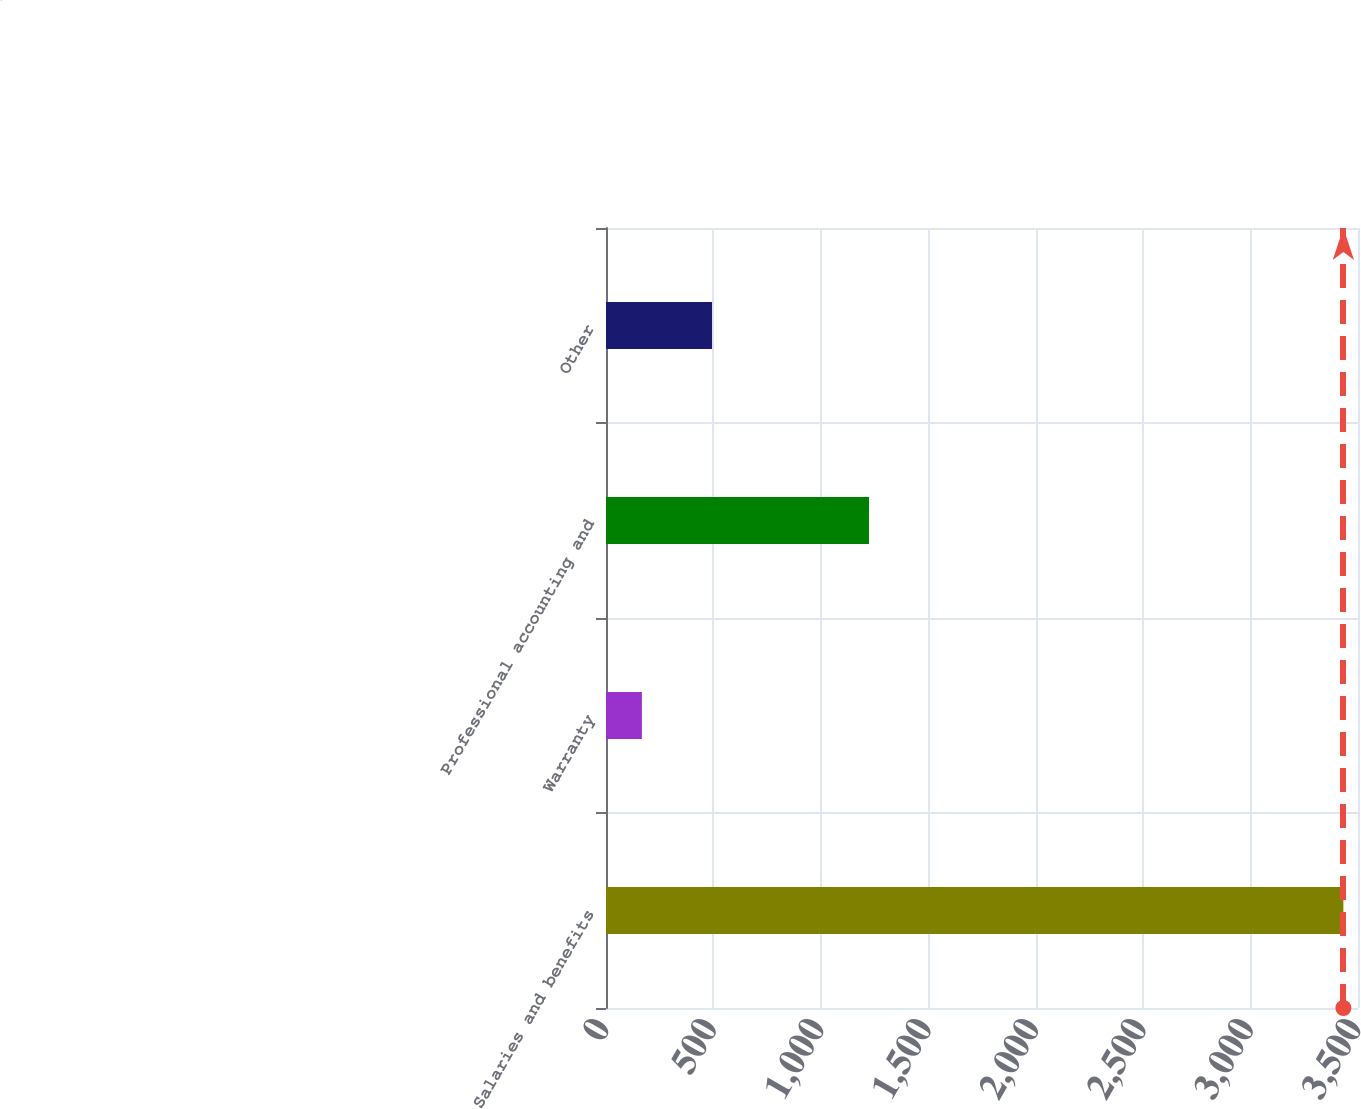Convert chart to OTSL. <chart><loc_0><loc_0><loc_500><loc_500><bar_chart><fcel>Salaries and benefits<fcel>Warranty<fcel>Professional accounting and<fcel>Other<nl><fcel>3432<fcel>167<fcel>1224<fcel>493.5<nl></chart> 